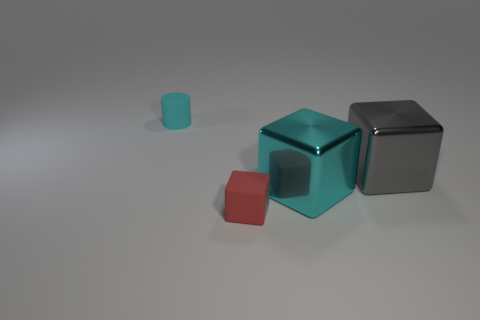Add 1 small red metallic blocks. How many objects exist? 5 Subtract all cylinders. How many objects are left? 3 Add 2 big cyan blocks. How many big cyan blocks exist? 3 Subtract 0 green balls. How many objects are left? 4 Subtract all small blue metal cubes. Subtract all big shiny objects. How many objects are left? 2 Add 4 big cyan metal things. How many big cyan metal things are left? 5 